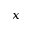Convert formula to latex. <formula><loc_0><loc_0><loc_500><loc_500>_ { x }</formula> 